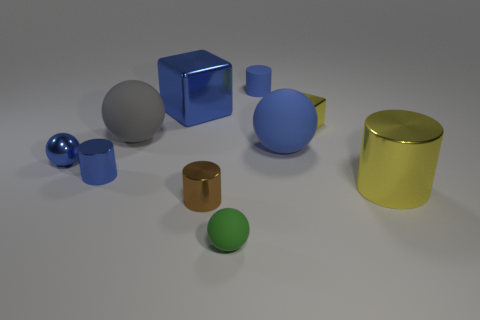There is a yellow object that is on the left side of the large yellow metallic thing; is there a big blue metal block that is on the right side of it?
Your answer should be compact. No. What is the large yellow thing made of?
Offer a very short reply. Metal. Are the blue cylinder behind the blue metallic cube and the small brown cylinder that is behind the green thing made of the same material?
Make the answer very short. No. Is there any other thing of the same color as the large cube?
Your answer should be compact. Yes. What is the color of the other large matte thing that is the same shape as the gray matte object?
Provide a short and direct response. Blue. How big is the shiny cylinder that is right of the large gray matte object and on the left side of the yellow shiny cube?
Ensure brevity in your answer.  Small. There is a big metal object that is behind the large cylinder; is it the same shape as the tiny brown metallic object on the right side of the large cube?
Give a very brief answer. No. The big thing that is the same color as the big cube is what shape?
Make the answer very short. Sphere. How many big yellow cylinders have the same material as the brown cylinder?
Make the answer very short. 1. The blue thing that is both in front of the big metallic block and right of the brown shiny cylinder has what shape?
Offer a very short reply. Sphere. 